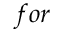<formula> <loc_0><loc_0><loc_500><loc_500>f o r</formula> 